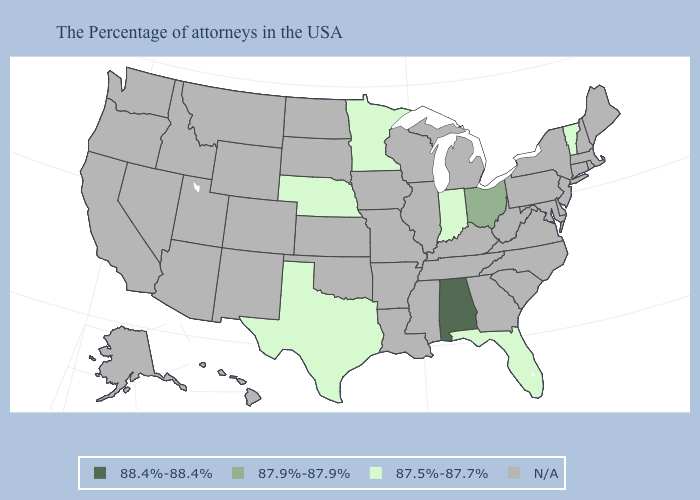What is the highest value in the USA?
Answer briefly. 88.4%-88.4%. Does Texas have the lowest value in the USA?
Quick response, please. Yes. What is the highest value in the USA?
Keep it brief. 88.4%-88.4%. What is the lowest value in the USA?
Keep it brief. 87.5%-87.7%. What is the highest value in the USA?
Concise answer only. 88.4%-88.4%. Name the states that have a value in the range 88.4%-88.4%?
Short answer required. Alabama. What is the value of Missouri?
Give a very brief answer. N/A. Name the states that have a value in the range 88.4%-88.4%?
Write a very short answer. Alabama. Which states have the highest value in the USA?
Quick response, please. Alabama. What is the value of Maryland?
Be succinct. N/A. Is the legend a continuous bar?
Keep it brief. No. What is the highest value in states that border Kansas?
Give a very brief answer. 87.5%-87.7%. What is the value of Connecticut?
Quick response, please. N/A. 